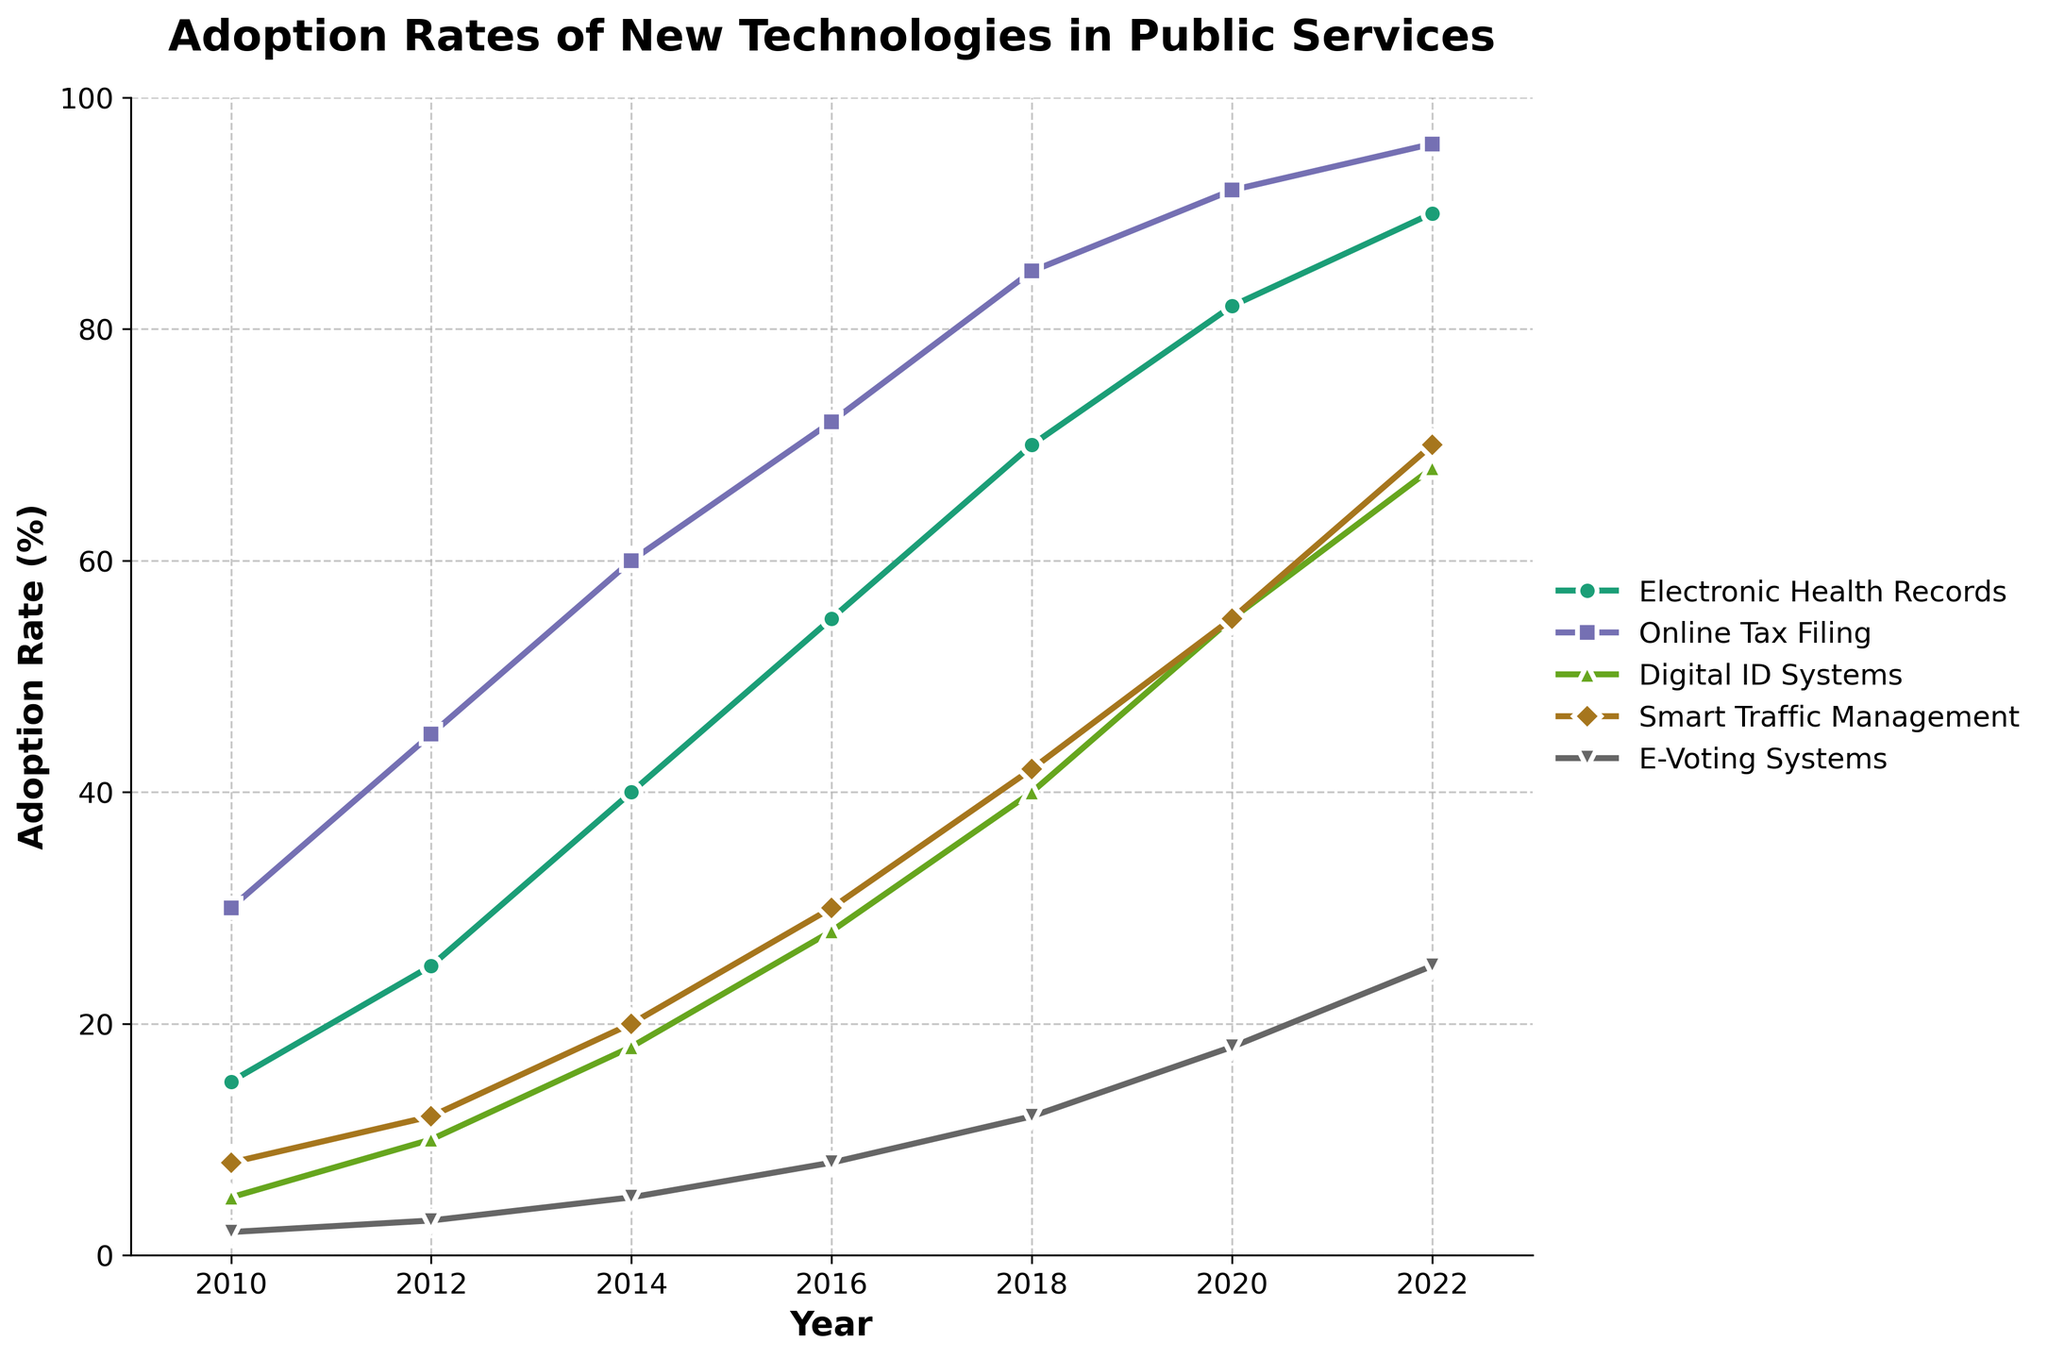What is the highest adoption rate for Electronic Health Records? To find the highest adoption rate for Electronic Health Records, we look at the line corresponding to Electronic Health Records and identify the peak point. The highest adoption rate is at the year 2022 with a value of 90%.
Answer: 90% Between which years did Online Tax Filing see the largest increase in adoption rate? First, we look at the adoption rates of Online Tax Filing over the years. We notice the increases: 30 to 45 (2010-2012), 45 to 60 (2012-2014), 60 to 72 (2014-2016), 72 to 85 (2016-2018), 85 to 92 (2018-2020), and 92 to 96 (2020-2022). The largest increase (15%) occurs between 2014 and 2016.
Answer: 2014-2016 Which technology saw the fastest adoption rate growth between 2018 and 2020? To determine which technology had the fastest growth, we calculate the increases for each technology between 2018 and 2020: 
Electronic Health Records: 82 - 70 = 12%
Online Tax Filing: 92 - 85 = 7%
Digital ID Systems: 55 - 40 = 15%
Smart Traffic Management: 55 - 42 = 13%
E-Voting Systems: 18 - 12 = 6%
Digital ID Systems shows the fastest growth with 15%.
Answer: Digital ID Systems What is the difference in adoption rate for Smart Traffic Management between 2010 and 2022? Subtract the 2010 adoption rate (8%) from the 2022 adoption rate (70%): 
70% - 8% = 62%
Answer: 62% Which technology had the least adoption rate in 2010? To find this, we compare the adoption rates for all technologies in the year 2010. The values are: Electronic Health Records (15%), Online Tax Filing (30%), Digital ID Systems (5%), Smart Traffic Management (8%), and E-Voting Systems (2%). E-Voting Systems had the lowest rate at 2%.
Answer: E-Voting Systems How many years did it take for Electronic Health Records to reach 40% adoption rate? Identify the year Electronic Health Records' adoption rate first reaches or exceeds 40%. This occurs in 2014. Starting from 2010, it takes 4 years (2014-2010).
Answer: 4 years What is the average adoption rate of E-Voting Systems across all years? Sum the adoption rates of E-Voting Systems for all years: 2 + 3 + 5 + 8 + 12 + 18 + 25 = 73%, then divide by the number of years (7): 73 / 7 ≈ 10.43%
Answer: 10.43% In which year did Digital ID Systems surpass 50% adoption rate? Look at the adoption rates for Digital ID Systems over the years and identify the year it first exceeds 50%. This happens in the year 2020 (55%).
Answer: 2020 Which technologies had a consistent increase in adoption rate every two years? Look at the lines for each technology and check if there is a steady increase every two years from 2010 to 2022:
- Electronic Health Records: Increase every year.
- Online Tax Filing: Increase every year.
- Digital ID Systems: Increase every year.
- Smart Traffic Management: Increase every year.
- E-Voting Systems: Increase every year.
All technologies have shown a consistent increase in adoption rate every two years.
Answer: All technologies What is the total adoption rate for Online Tax Filing across all years? Sum the adoption rates of Online Tax Filing for all years: 30 + 45 + 60 + 72 + 85 + 92 + 96 = 480%
Answer: 480% 